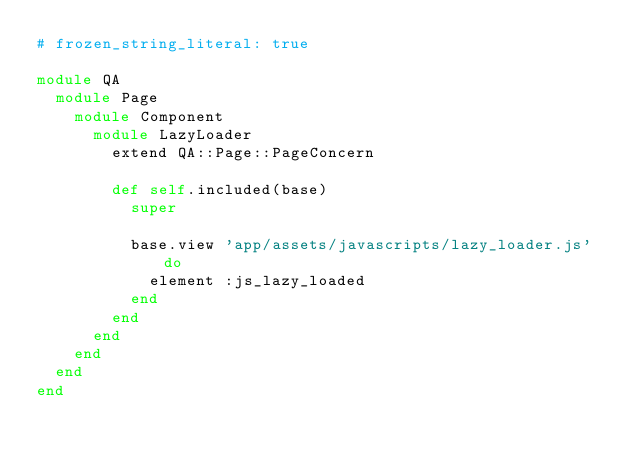<code> <loc_0><loc_0><loc_500><loc_500><_Ruby_># frozen_string_literal: true

module QA
  module Page
    module Component
      module LazyLoader
        extend QA::Page::PageConcern

        def self.included(base)
          super

          base.view 'app/assets/javascripts/lazy_loader.js' do
            element :js_lazy_loaded
          end
        end
      end
    end
  end
end
</code> 